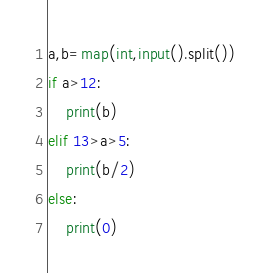Convert code to text. <code><loc_0><loc_0><loc_500><loc_500><_Python_>a,b=map(int,input().split())
if a>12:
    print(b)
elif 13>a>5:
    print(b/2)
else:
    print(0)
</code> 